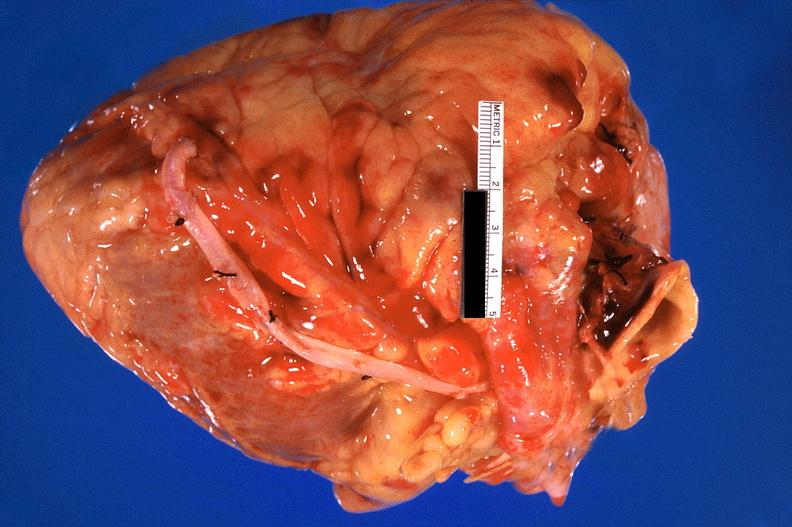s cardiovascular present?
Answer the question using a single word or phrase. Yes 